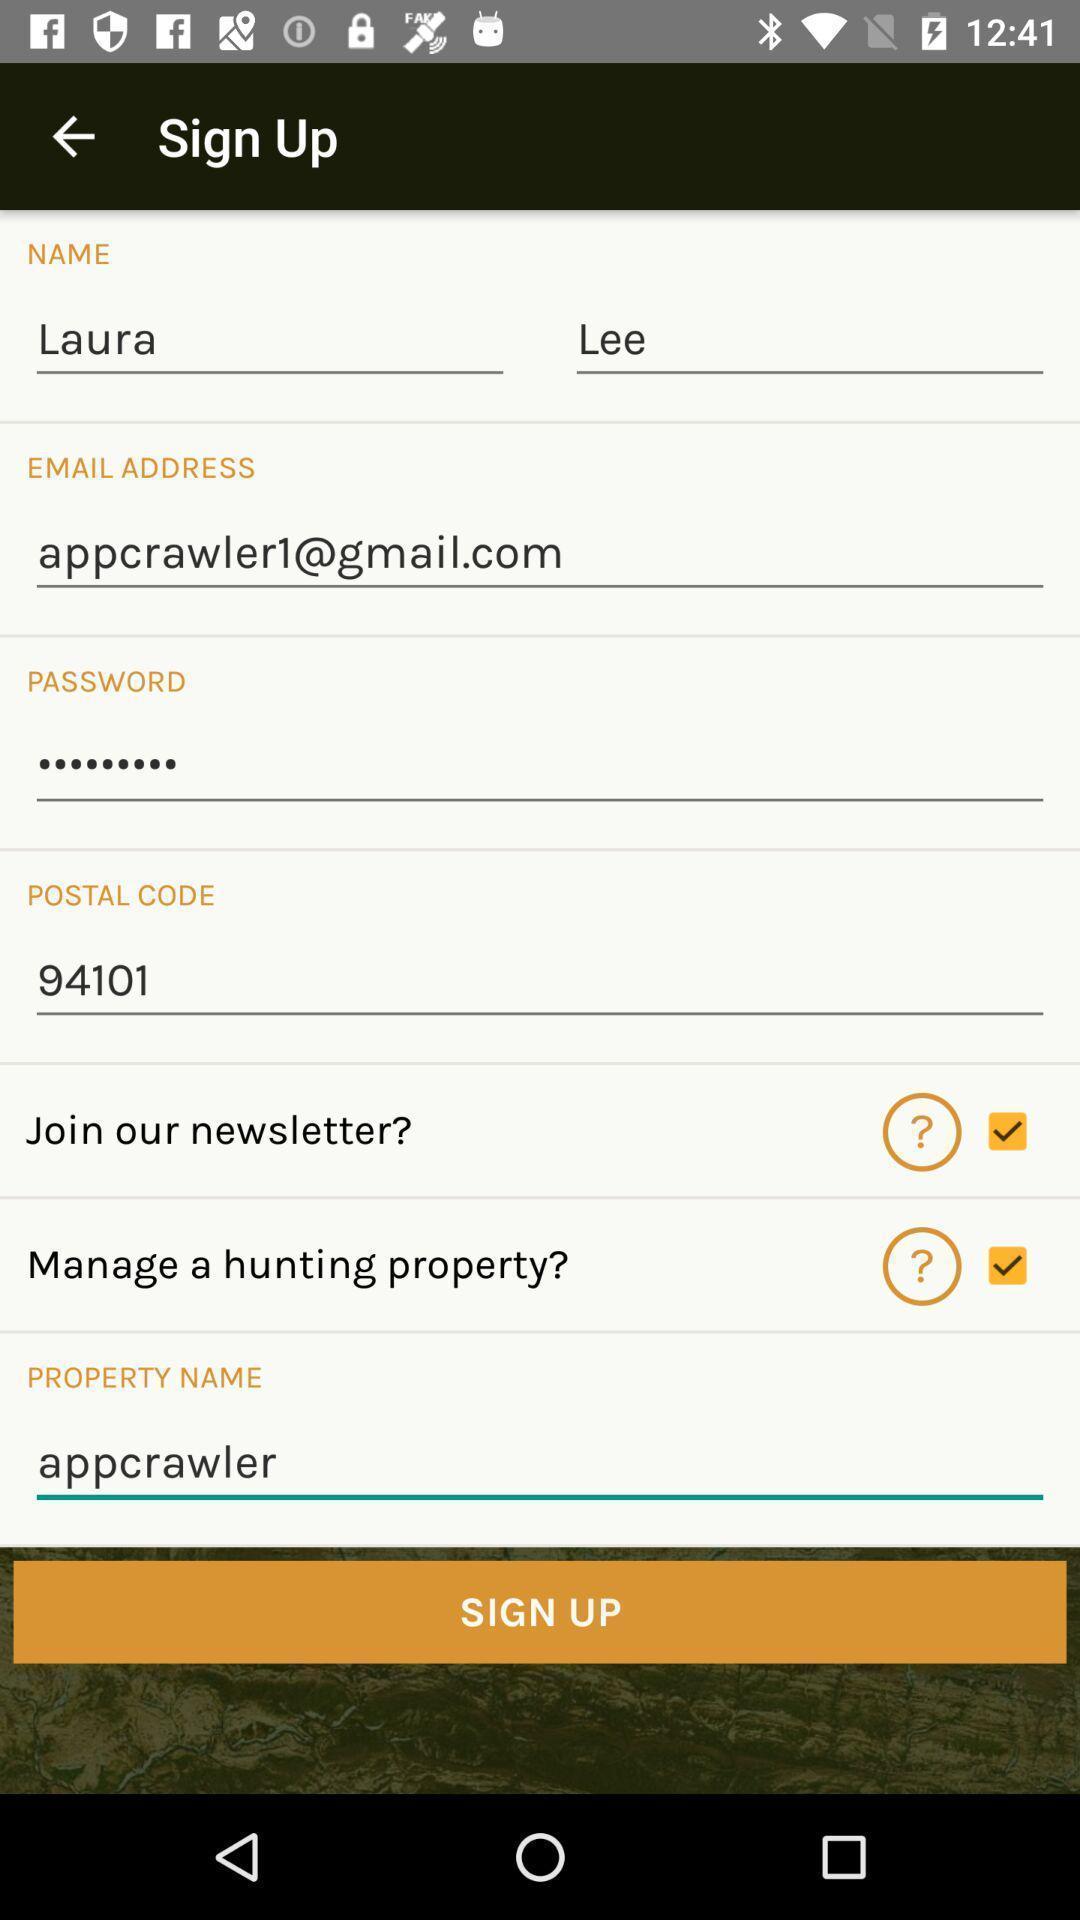What details can you identify in this image? Sign up profile page of a social app. 